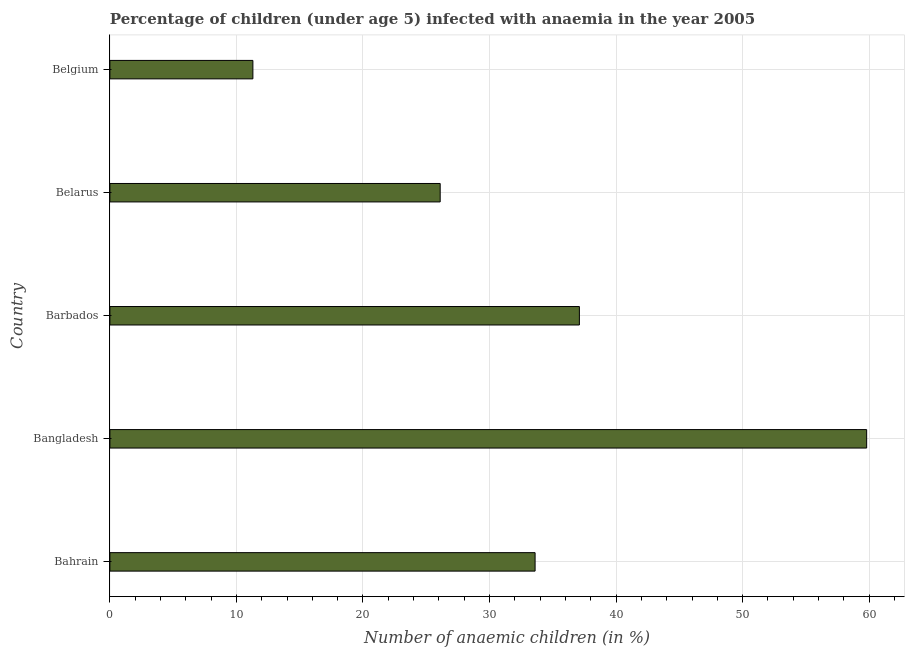Does the graph contain any zero values?
Give a very brief answer. No. Does the graph contain grids?
Offer a very short reply. Yes. What is the title of the graph?
Your answer should be very brief. Percentage of children (under age 5) infected with anaemia in the year 2005. What is the label or title of the X-axis?
Keep it short and to the point. Number of anaemic children (in %). What is the label or title of the Y-axis?
Your response must be concise. Country. What is the number of anaemic children in Bangladesh?
Provide a succinct answer. 59.8. Across all countries, what is the maximum number of anaemic children?
Your answer should be very brief. 59.8. Across all countries, what is the minimum number of anaemic children?
Provide a short and direct response. 11.3. In which country was the number of anaemic children maximum?
Offer a very short reply. Bangladesh. What is the sum of the number of anaemic children?
Keep it short and to the point. 167.9. What is the difference between the number of anaemic children in Bangladesh and Belarus?
Keep it short and to the point. 33.7. What is the average number of anaemic children per country?
Ensure brevity in your answer.  33.58. What is the median number of anaemic children?
Your response must be concise. 33.6. What is the ratio of the number of anaemic children in Bahrain to that in Belgium?
Your response must be concise. 2.97. What is the difference between the highest and the second highest number of anaemic children?
Make the answer very short. 22.7. Is the sum of the number of anaemic children in Bangladesh and Belarus greater than the maximum number of anaemic children across all countries?
Provide a succinct answer. Yes. What is the difference between the highest and the lowest number of anaemic children?
Your response must be concise. 48.5. How many countries are there in the graph?
Ensure brevity in your answer.  5. What is the difference between two consecutive major ticks on the X-axis?
Your response must be concise. 10. What is the Number of anaemic children (in %) of Bahrain?
Make the answer very short. 33.6. What is the Number of anaemic children (in %) of Bangladesh?
Make the answer very short. 59.8. What is the Number of anaemic children (in %) in Barbados?
Provide a succinct answer. 37.1. What is the Number of anaemic children (in %) in Belarus?
Your answer should be compact. 26.1. What is the difference between the Number of anaemic children (in %) in Bahrain and Bangladesh?
Provide a short and direct response. -26.2. What is the difference between the Number of anaemic children (in %) in Bahrain and Belarus?
Your answer should be very brief. 7.5. What is the difference between the Number of anaemic children (in %) in Bahrain and Belgium?
Offer a terse response. 22.3. What is the difference between the Number of anaemic children (in %) in Bangladesh and Barbados?
Offer a very short reply. 22.7. What is the difference between the Number of anaemic children (in %) in Bangladesh and Belarus?
Make the answer very short. 33.7. What is the difference between the Number of anaemic children (in %) in Bangladesh and Belgium?
Provide a short and direct response. 48.5. What is the difference between the Number of anaemic children (in %) in Barbados and Belgium?
Keep it short and to the point. 25.8. What is the difference between the Number of anaemic children (in %) in Belarus and Belgium?
Keep it short and to the point. 14.8. What is the ratio of the Number of anaemic children (in %) in Bahrain to that in Bangladesh?
Offer a terse response. 0.56. What is the ratio of the Number of anaemic children (in %) in Bahrain to that in Barbados?
Your response must be concise. 0.91. What is the ratio of the Number of anaemic children (in %) in Bahrain to that in Belarus?
Keep it short and to the point. 1.29. What is the ratio of the Number of anaemic children (in %) in Bahrain to that in Belgium?
Your answer should be very brief. 2.97. What is the ratio of the Number of anaemic children (in %) in Bangladesh to that in Barbados?
Your response must be concise. 1.61. What is the ratio of the Number of anaemic children (in %) in Bangladesh to that in Belarus?
Your response must be concise. 2.29. What is the ratio of the Number of anaemic children (in %) in Bangladesh to that in Belgium?
Give a very brief answer. 5.29. What is the ratio of the Number of anaemic children (in %) in Barbados to that in Belarus?
Give a very brief answer. 1.42. What is the ratio of the Number of anaemic children (in %) in Barbados to that in Belgium?
Make the answer very short. 3.28. What is the ratio of the Number of anaemic children (in %) in Belarus to that in Belgium?
Provide a short and direct response. 2.31. 